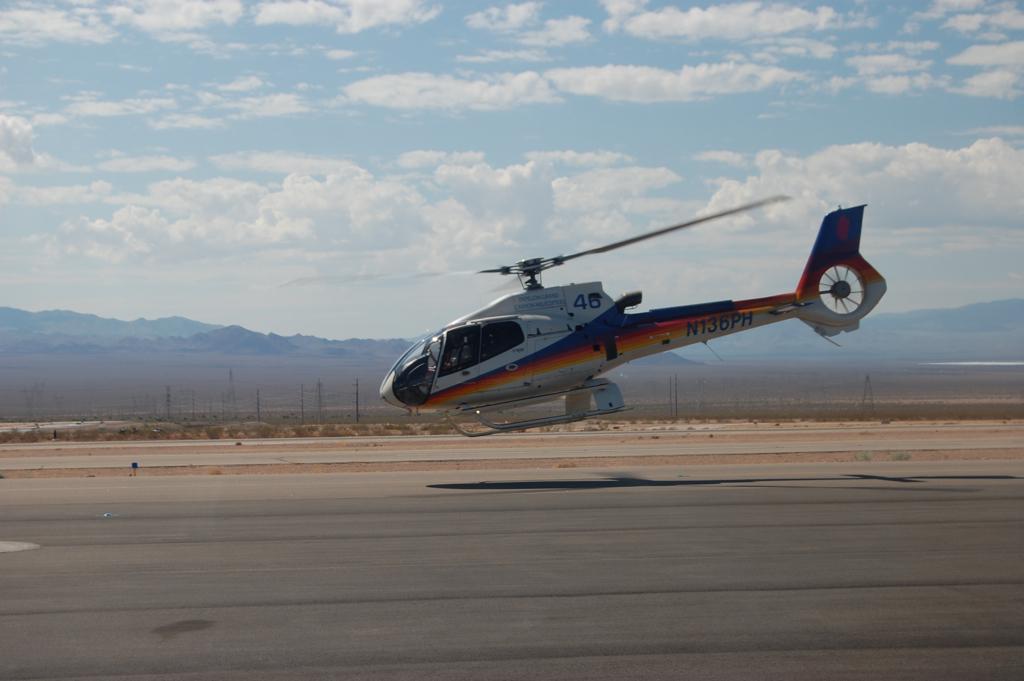How would you summarize this image in a sentence or two? In the picture there is a helicopter landing on the ground and in the background there are many mountains. 